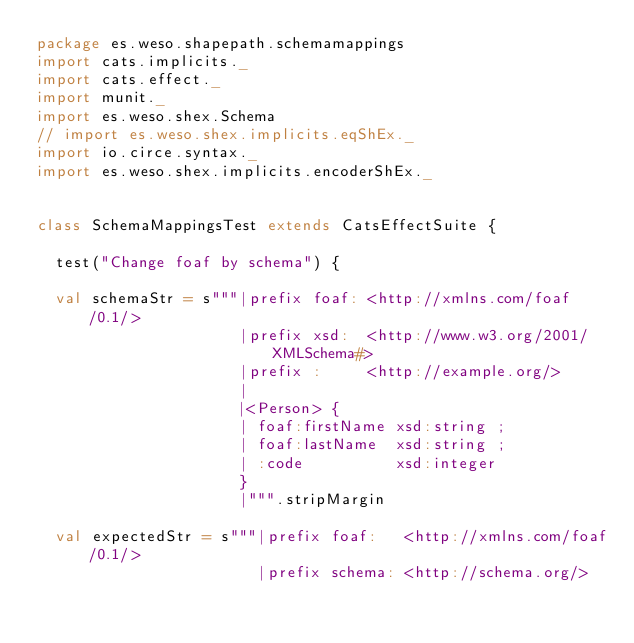<code> <loc_0><loc_0><loc_500><loc_500><_Scala_>package es.weso.shapepath.schemamappings
import cats.implicits._
import cats.effect._
import munit._
import es.weso.shex.Schema
// import es.weso.shex.implicits.eqShEx._
import io.circe.syntax._
import es.weso.shex.implicits.encoderShEx._


class SchemaMappingsTest extends CatsEffectSuite {

  test("Change foaf by schema") {

  val schemaStr = s"""|prefix foaf: <http://xmlns.com/foaf/0.1/>
                      |prefix xsd:  <http://www.w3.org/2001/XMLSchema#>
                      |prefix :     <http://example.org/>
                      |
                      |<Person> {
                      | foaf:firstName xsd:string ;
                      | foaf:lastName  xsd:string ;
                      | :code          xsd:integer
                      }
                      |""".stripMargin

  val expectedStr = s"""|prefix foaf:   <http://xmlns.com/foaf/0.1/>
                        |prefix schema: <http://schema.org/></code> 